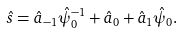Convert formula to latex. <formula><loc_0><loc_0><loc_500><loc_500>\hat { s } = \hat { a } _ { - 1 } \hat { \psi } _ { 0 } ^ { - 1 } + \hat { a } _ { 0 } + \hat { a } _ { 1 } \hat { \psi } _ { 0 } .</formula> 